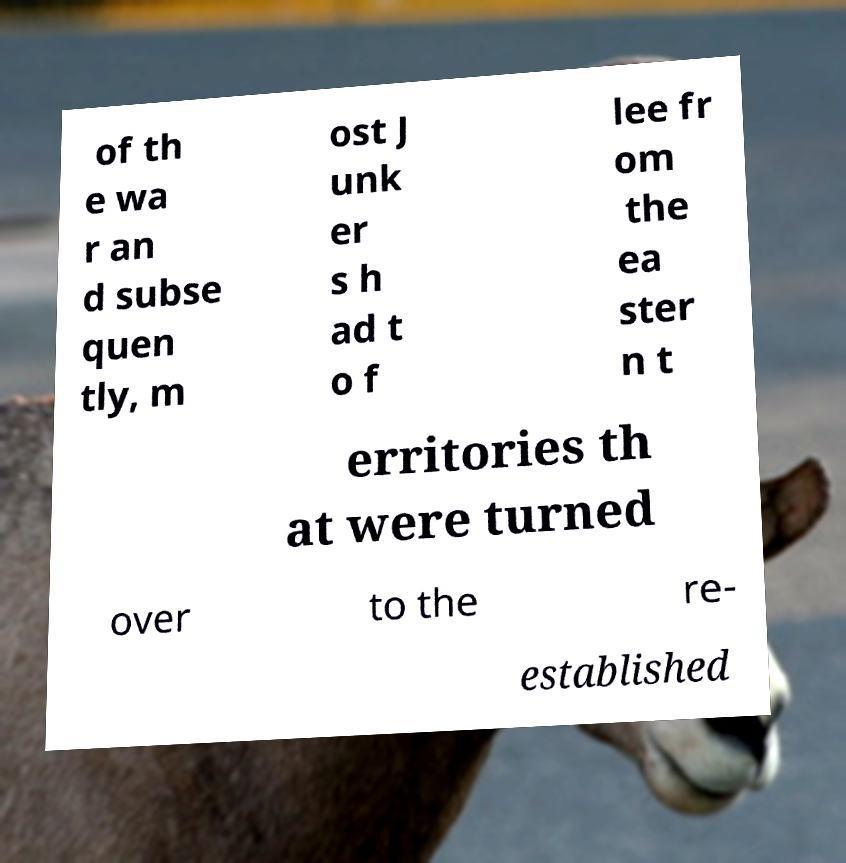Can you accurately transcribe the text from the provided image for me? of th e wa r an d subse quen tly, m ost J unk er s h ad t o f lee fr om the ea ster n t erritories th at were turned over to the re- established 